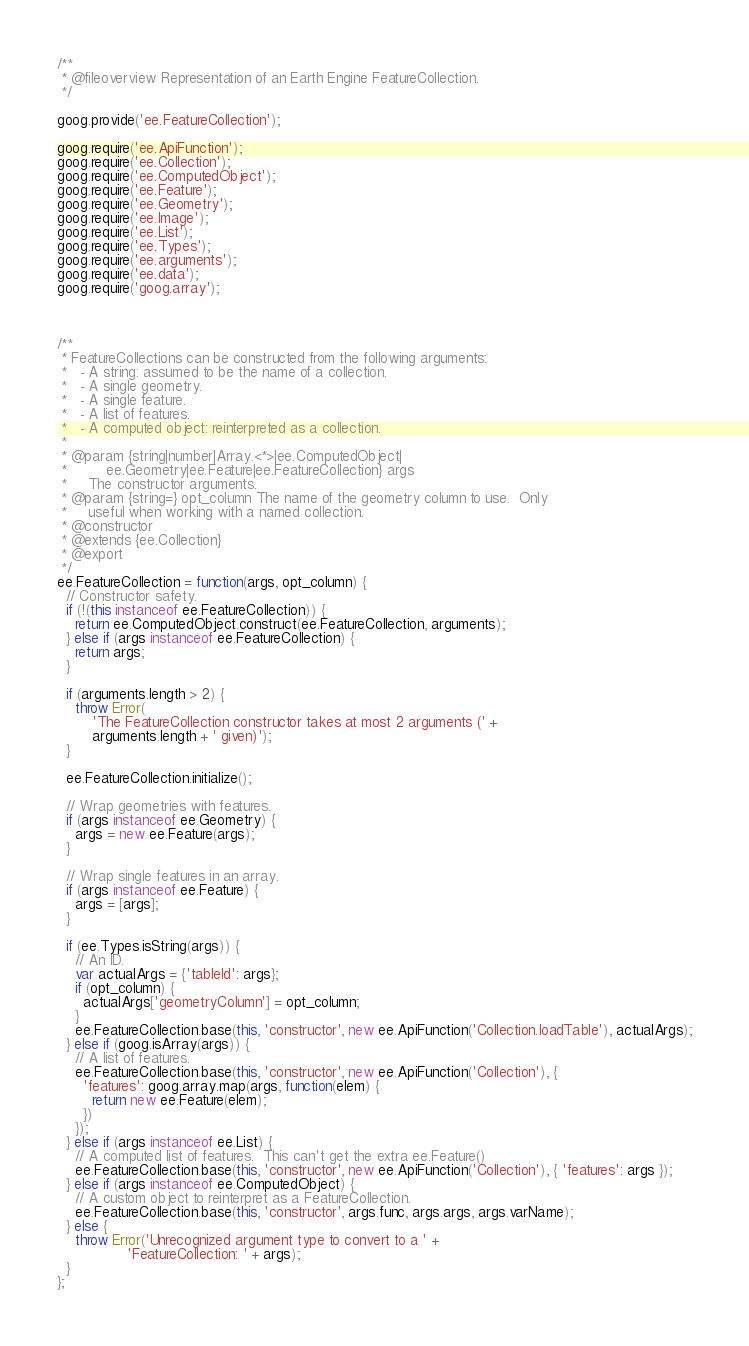Convert code to text. <code><loc_0><loc_0><loc_500><loc_500><_JavaScript_>/**
 * @fileoverview Representation of an Earth Engine FeatureCollection.
 */

goog.provide('ee.FeatureCollection');

goog.require('ee.ApiFunction');
goog.require('ee.Collection');
goog.require('ee.ComputedObject');
goog.require('ee.Feature');
goog.require('ee.Geometry');
goog.require('ee.Image');
goog.require('ee.List');
goog.require('ee.Types');
goog.require('ee.arguments');
goog.require('ee.data');
goog.require('goog.array');



/**
 * FeatureCollections can be constructed from the following arguments:
 *   - A string: assumed to be the name of a collection.
 *   - A single geometry.
 *   - A single feature.
 *   - A list of features.
 *   - A computed object: reinterpreted as a collection.
 *
 * @param {string|number|Array.<*>|ee.ComputedObject|
 *         ee.Geometry|ee.Feature|ee.FeatureCollection} args
 *     The constructor arguments.
 * @param {string=} opt_column The name of the geometry column to use.  Only
 *     useful when working with a named collection.
 * @constructor
 * @extends {ee.Collection}
 * @export
 */
ee.FeatureCollection = function(args, opt_column) {
  // Constructor safety.
  if (!(this instanceof ee.FeatureCollection)) {
    return ee.ComputedObject.construct(ee.FeatureCollection, arguments);
  } else if (args instanceof ee.FeatureCollection) {
    return args;
  }

  if (arguments.length > 2) {
    throw Error(
        'The FeatureCollection constructor takes at most 2 arguments (' +
        arguments.length + ' given)');
  }

  ee.FeatureCollection.initialize();

  // Wrap geometries with features.
  if (args instanceof ee.Geometry) {
    args = new ee.Feature(args);
  }

  // Wrap single features in an array.
  if (args instanceof ee.Feature) {
    args = [args];
  }

  if (ee.Types.isString(args)) {
    // An ID.
    var actualArgs = {'tableId': args};
    if (opt_column) {
      actualArgs['geometryColumn'] = opt_column;
    }
    ee.FeatureCollection.base(this, 'constructor', new ee.ApiFunction('Collection.loadTable'), actualArgs);
  } else if (goog.isArray(args)) {
    // A list of features.
    ee.FeatureCollection.base(this, 'constructor', new ee.ApiFunction('Collection'), {
      'features': goog.array.map(args, function(elem) {
        return new ee.Feature(elem);
      })
    });
  } else if (args instanceof ee.List) {
    // A computed list of features.  This can't get the extra ee.Feature()
    ee.FeatureCollection.base(this, 'constructor', new ee.ApiFunction('Collection'), { 'features': args });
  } else if (args instanceof ee.ComputedObject) {
    // A custom object to reinterpret as a FeatureCollection.
    ee.FeatureCollection.base(this, 'constructor', args.func, args.args, args.varName);
  } else {
    throw Error('Unrecognized argument type to convert to a ' +
                'FeatureCollection: ' + args);
  }
};</code> 